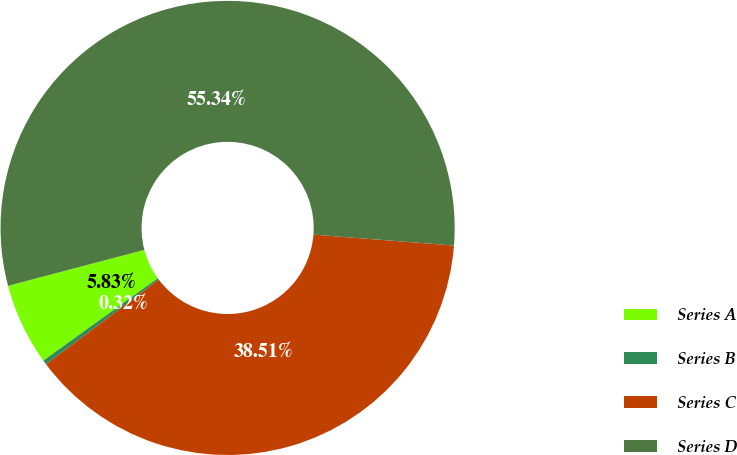Convert chart. <chart><loc_0><loc_0><loc_500><loc_500><pie_chart><fcel>Series A<fcel>Series B<fcel>Series C<fcel>Series D<nl><fcel>5.83%<fcel>0.32%<fcel>38.51%<fcel>55.34%<nl></chart> 